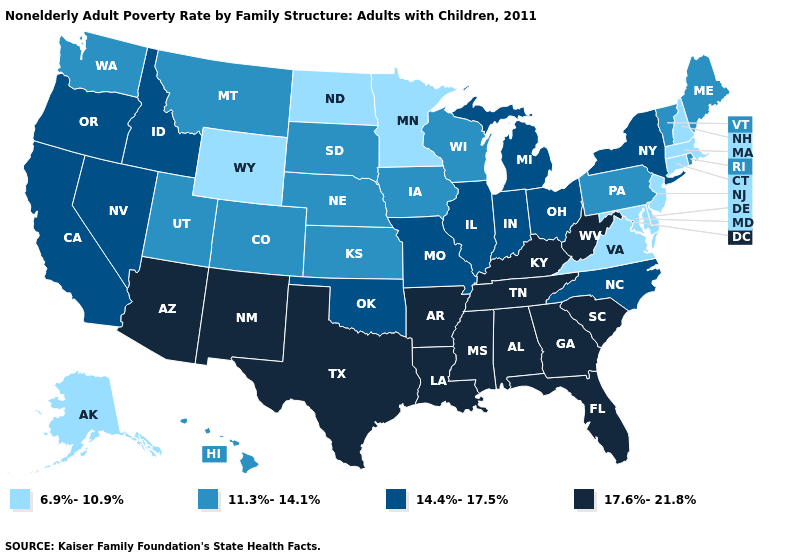What is the highest value in the USA?
Quick response, please. 17.6%-21.8%. Does Kansas have the same value as Rhode Island?
Concise answer only. Yes. Does Connecticut have the lowest value in the Northeast?
Be succinct. Yes. Name the states that have a value in the range 17.6%-21.8%?
Concise answer only. Alabama, Arizona, Arkansas, Florida, Georgia, Kentucky, Louisiana, Mississippi, New Mexico, South Carolina, Tennessee, Texas, West Virginia. What is the value of Ohio?
Answer briefly. 14.4%-17.5%. Does Indiana have the lowest value in the USA?
Concise answer only. No. Which states have the highest value in the USA?
Answer briefly. Alabama, Arizona, Arkansas, Florida, Georgia, Kentucky, Louisiana, Mississippi, New Mexico, South Carolina, Tennessee, Texas, West Virginia. What is the value of Minnesota?
Quick response, please. 6.9%-10.9%. What is the lowest value in the USA?
Be succinct. 6.9%-10.9%. Name the states that have a value in the range 6.9%-10.9%?
Short answer required. Alaska, Connecticut, Delaware, Maryland, Massachusetts, Minnesota, New Hampshire, New Jersey, North Dakota, Virginia, Wyoming. Is the legend a continuous bar?
Write a very short answer. No. Which states have the highest value in the USA?
Quick response, please. Alabama, Arizona, Arkansas, Florida, Georgia, Kentucky, Louisiana, Mississippi, New Mexico, South Carolina, Tennessee, Texas, West Virginia. What is the lowest value in the USA?
Give a very brief answer. 6.9%-10.9%. Does the first symbol in the legend represent the smallest category?
Answer briefly. Yes. Does Wyoming have the lowest value in the West?
Be succinct. Yes. 